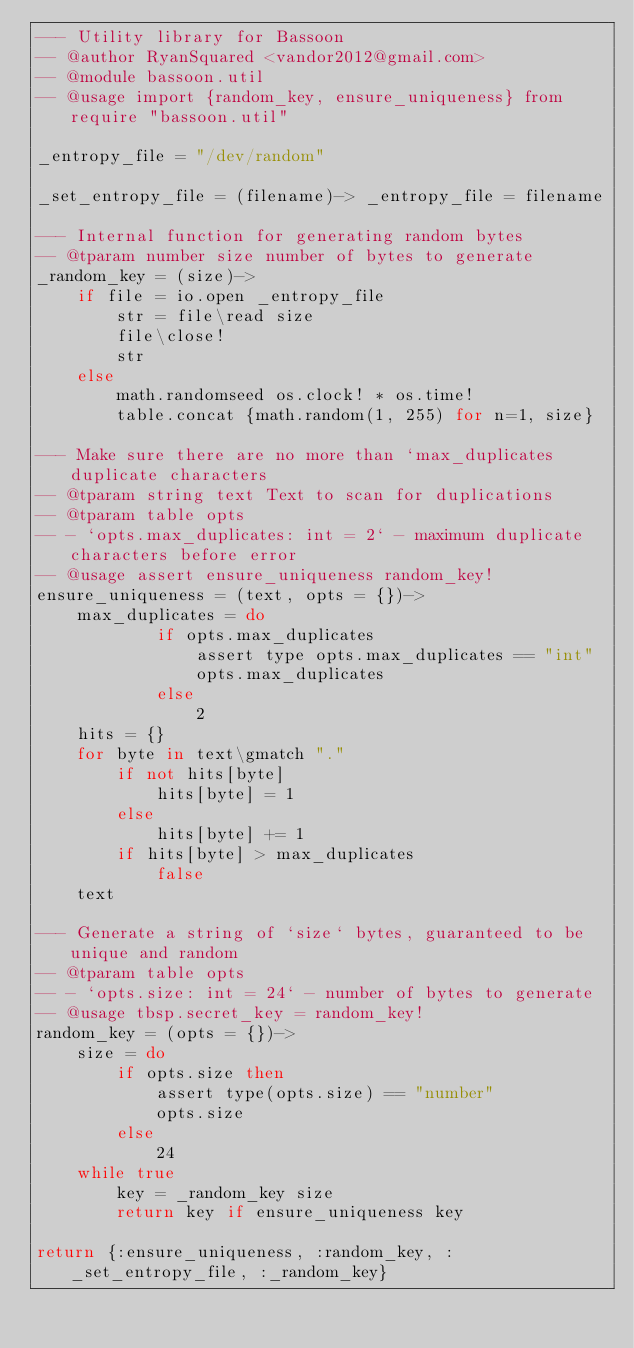Convert code to text. <code><loc_0><loc_0><loc_500><loc_500><_MoonScript_>--- Utility library for Bassoon
-- @author RyanSquared <vandor2012@gmail.com>
-- @module bassoon.util
-- @usage import {random_key, ensure_uniqueness} from require "bassoon.util"

_entropy_file = "/dev/random"

_set_entropy_file = (filename)-> _entropy_file = filename

--- Internal function for generating random bytes
-- @tparam number size number of bytes to generate
_random_key = (size)->
	if file = io.open _entropy_file
		str = file\read size
		file\close!
		str
	else
		math.randomseed os.clock! * os.time!
		table.concat {math.random(1, 255) for n=1, size}

--- Make sure there are no more than `max_duplicates duplicate characters
-- @tparam string text Text to scan for duplications
-- @tparam table opts
-- - `opts.max_duplicates: int = 2` - maximum duplicate characters before error
-- @usage assert ensure_uniqueness random_key!
ensure_uniqueness = (text, opts = {})->
	max_duplicates = do
			if opts.max_duplicates
				assert type opts.max_duplicates == "int"
				opts.max_duplicates
			else
				2
	hits = {}
	for byte in text\gmatch "."
		if not hits[byte]
			hits[byte] = 1
		else
			hits[byte] += 1
		if hits[byte] > max_duplicates
			false
	text

--- Generate a string of `size` bytes, guaranteed to be unique and random
-- @tparam table opts
-- - `opts.size: int = 24` - number of bytes to generate
-- @usage tbsp.secret_key = random_key!
random_key = (opts = {})->
	size = do
		if opts.size then
			assert type(opts.size) == "number"
			opts.size
		else
			24
	while true
		key = _random_key size
		return key if ensure_uniqueness key

return {:ensure_uniqueness, :random_key, :_set_entropy_file, :_random_key}
</code> 